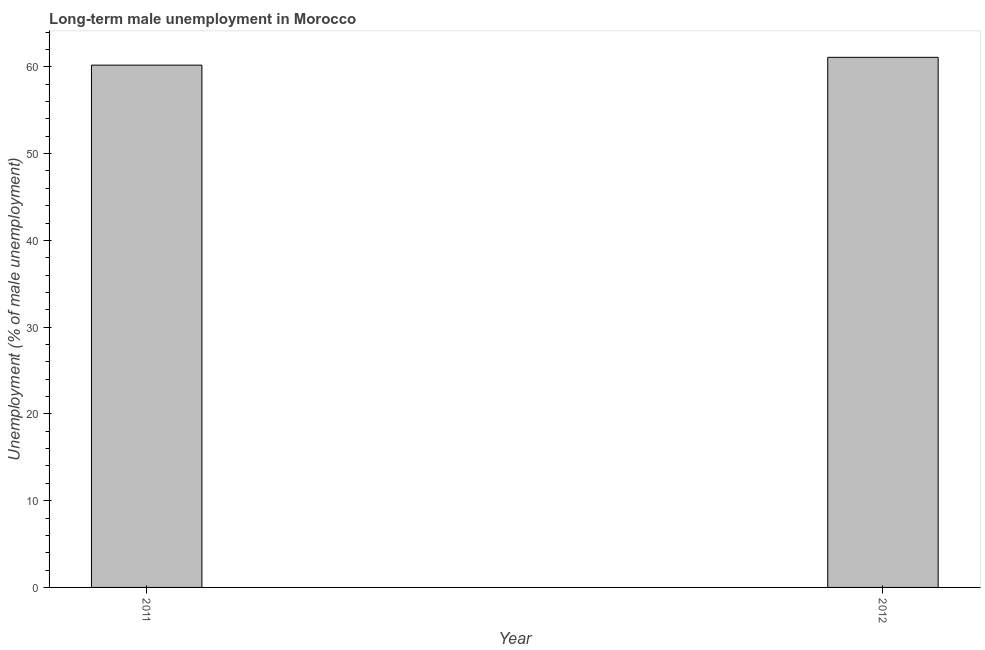Does the graph contain any zero values?
Your answer should be compact. No. What is the title of the graph?
Your answer should be very brief. Long-term male unemployment in Morocco. What is the label or title of the Y-axis?
Provide a succinct answer. Unemployment (% of male unemployment). What is the long-term male unemployment in 2011?
Make the answer very short. 60.2. Across all years, what is the maximum long-term male unemployment?
Your answer should be very brief. 61.1. Across all years, what is the minimum long-term male unemployment?
Provide a short and direct response. 60.2. In which year was the long-term male unemployment maximum?
Your answer should be very brief. 2012. In which year was the long-term male unemployment minimum?
Provide a short and direct response. 2011. What is the sum of the long-term male unemployment?
Provide a succinct answer. 121.3. What is the difference between the long-term male unemployment in 2011 and 2012?
Ensure brevity in your answer.  -0.9. What is the average long-term male unemployment per year?
Provide a succinct answer. 60.65. What is the median long-term male unemployment?
Offer a very short reply. 60.65. In how many years, is the long-term male unemployment greater than the average long-term male unemployment taken over all years?
Offer a very short reply. 1. How many bars are there?
Make the answer very short. 2. What is the difference between two consecutive major ticks on the Y-axis?
Your answer should be very brief. 10. What is the Unemployment (% of male unemployment) of 2011?
Your answer should be compact. 60.2. What is the Unemployment (% of male unemployment) of 2012?
Your answer should be very brief. 61.1. What is the difference between the Unemployment (% of male unemployment) in 2011 and 2012?
Offer a terse response. -0.9. What is the ratio of the Unemployment (% of male unemployment) in 2011 to that in 2012?
Your answer should be very brief. 0.98. 